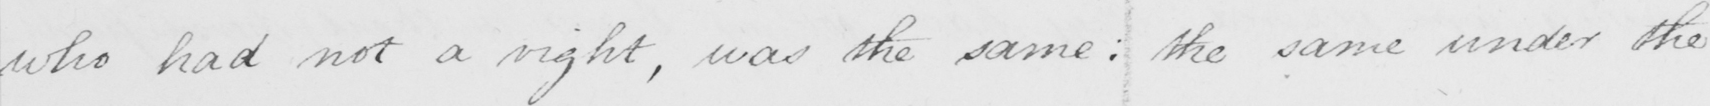Can you read and transcribe this handwriting? who had not a right , was the same :  the same under the 